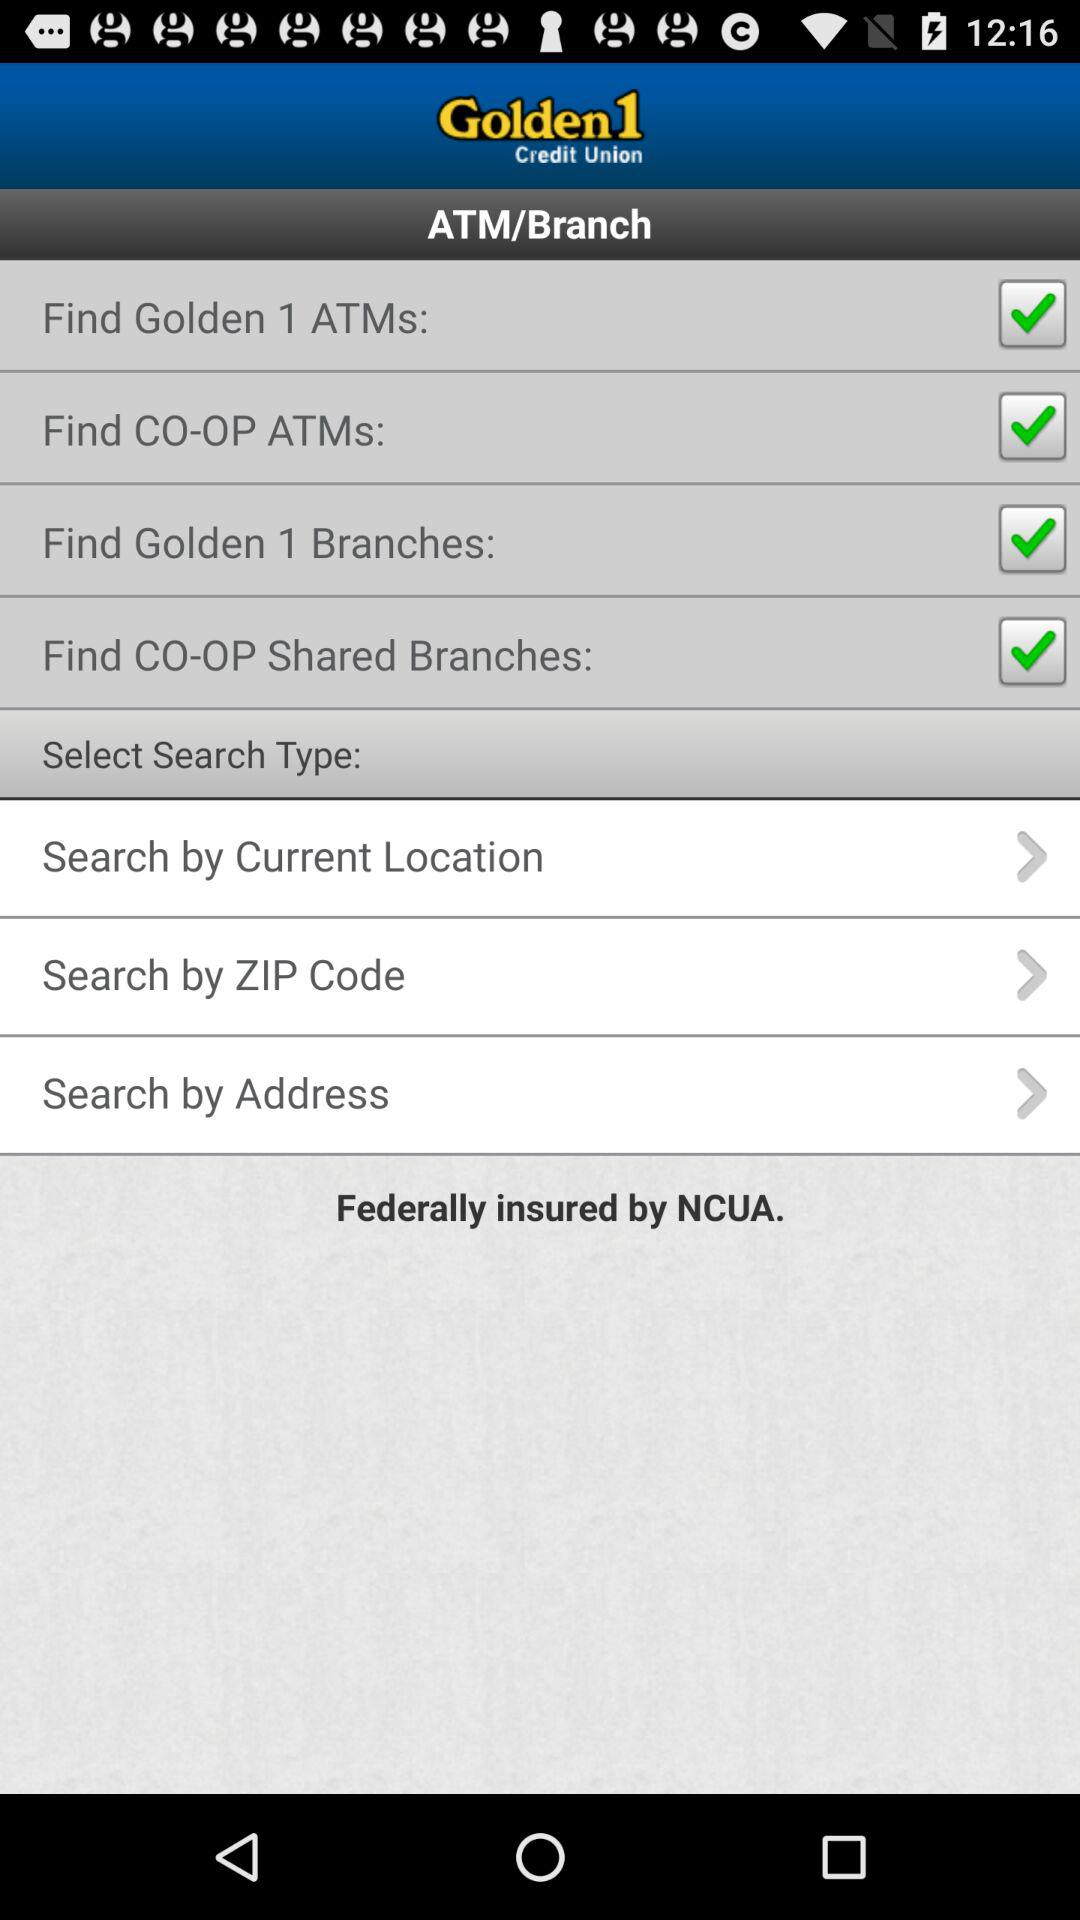How many options are there for the user to select a search type?
Answer the question using a single word or phrase. 4 